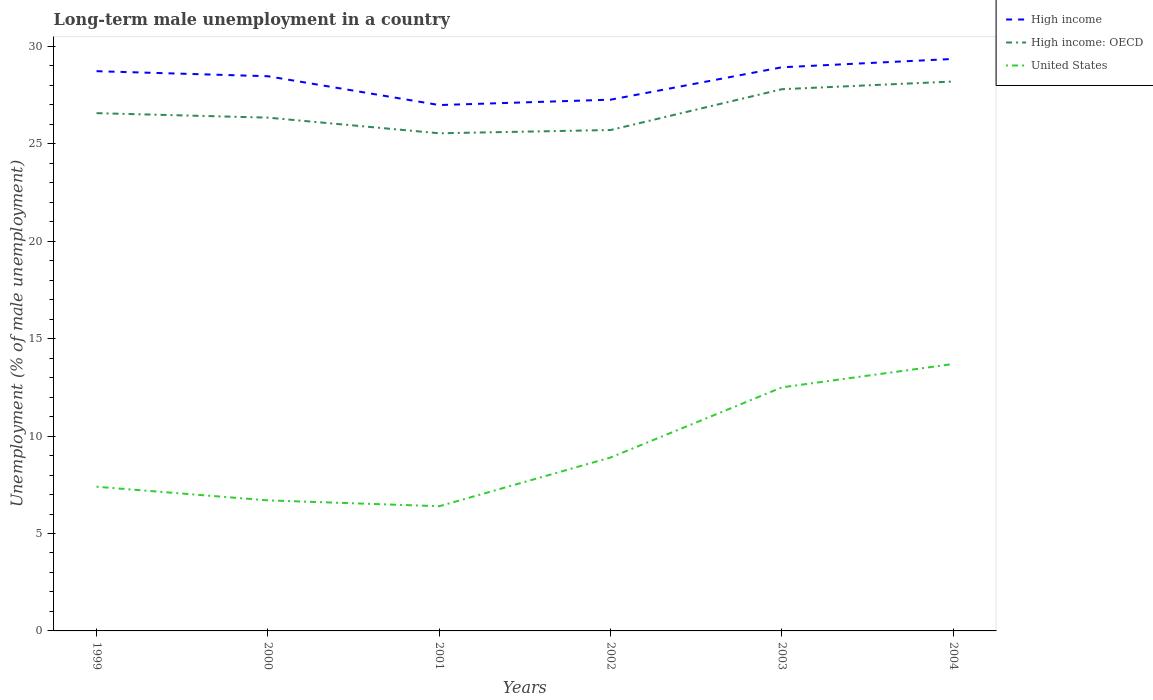Does the line corresponding to United States intersect with the line corresponding to High income?
Your response must be concise. No. Across all years, what is the maximum percentage of long-term unemployed male population in High income: OECD?
Provide a short and direct response. 25.54. What is the total percentage of long-term unemployed male population in High income in the graph?
Give a very brief answer. -2.37. What is the difference between the highest and the second highest percentage of long-term unemployed male population in High income?
Provide a succinct answer. 2.37. What is the difference between the highest and the lowest percentage of long-term unemployed male population in United States?
Offer a terse response. 2. Is the percentage of long-term unemployed male population in High income: OECD strictly greater than the percentage of long-term unemployed male population in High income over the years?
Your answer should be compact. Yes. Does the graph contain grids?
Provide a short and direct response. No. Where does the legend appear in the graph?
Give a very brief answer. Top right. How many legend labels are there?
Ensure brevity in your answer.  3. What is the title of the graph?
Your answer should be compact. Long-term male unemployment in a country. What is the label or title of the X-axis?
Offer a very short reply. Years. What is the label or title of the Y-axis?
Offer a very short reply. Unemployment (% of male unemployment). What is the Unemployment (% of male unemployment) in High income in 1999?
Make the answer very short. 28.73. What is the Unemployment (% of male unemployment) in High income: OECD in 1999?
Provide a short and direct response. 26.57. What is the Unemployment (% of male unemployment) of United States in 1999?
Your answer should be compact. 7.4. What is the Unemployment (% of male unemployment) in High income in 2000?
Provide a short and direct response. 28.47. What is the Unemployment (% of male unemployment) of High income: OECD in 2000?
Make the answer very short. 26.34. What is the Unemployment (% of male unemployment) in United States in 2000?
Give a very brief answer. 6.7. What is the Unemployment (% of male unemployment) of High income in 2001?
Ensure brevity in your answer.  26.99. What is the Unemployment (% of male unemployment) in High income: OECD in 2001?
Your answer should be very brief. 25.54. What is the Unemployment (% of male unemployment) in United States in 2001?
Your response must be concise. 6.4. What is the Unemployment (% of male unemployment) of High income in 2002?
Provide a succinct answer. 27.26. What is the Unemployment (% of male unemployment) in High income: OECD in 2002?
Make the answer very short. 25.71. What is the Unemployment (% of male unemployment) in United States in 2002?
Your answer should be compact. 8.9. What is the Unemployment (% of male unemployment) of High income in 2003?
Your answer should be very brief. 28.93. What is the Unemployment (% of male unemployment) in High income: OECD in 2003?
Your response must be concise. 27.8. What is the Unemployment (% of male unemployment) of High income in 2004?
Ensure brevity in your answer.  29.36. What is the Unemployment (% of male unemployment) in High income: OECD in 2004?
Offer a terse response. 28.2. What is the Unemployment (% of male unemployment) in United States in 2004?
Make the answer very short. 13.7. Across all years, what is the maximum Unemployment (% of male unemployment) of High income?
Ensure brevity in your answer.  29.36. Across all years, what is the maximum Unemployment (% of male unemployment) in High income: OECD?
Your response must be concise. 28.2. Across all years, what is the maximum Unemployment (% of male unemployment) of United States?
Offer a terse response. 13.7. Across all years, what is the minimum Unemployment (% of male unemployment) in High income?
Offer a terse response. 26.99. Across all years, what is the minimum Unemployment (% of male unemployment) of High income: OECD?
Give a very brief answer. 25.54. Across all years, what is the minimum Unemployment (% of male unemployment) of United States?
Keep it short and to the point. 6.4. What is the total Unemployment (% of male unemployment) in High income in the graph?
Make the answer very short. 169.73. What is the total Unemployment (% of male unemployment) of High income: OECD in the graph?
Offer a terse response. 160.16. What is the total Unemployment (% of male unemployment) of United States in the graph?
Make the answer very short. 55.6. What is the difference between the Unemployment (% of male unemployment) in High income in 1999 and that in 2000?
Ensure brevity in your answer.  0.26. What is the difference between the Unemployment (% of male unemployment) in High income: OECD in 1999 and that in 2000?
Your answer should be very brief. 0.23. What is the difference between the Unemployment (% of male unemployment) of High income in 1999 and that in 2001?
Your response must be concise. 1.74. What is the difference between the Unemployment (% of male unemployment) in High income: OECD in 1999 and that in 2001?
Your answer should be very brief. 1.03. What is the difference between the Unemployment (% of male unemployment) of United States in 1999 and that in 2001?
Provide a succinct answer. 1. What is the difference between the Unemployment (% of male unemployment) in High income in 1999 and that in 2002?
Ensure brevity in your answer.  1.46. What is the difference between the Unemployment (% of male unemployment) in High income: OECD in 1999 and that in 2002?
Provide a short and direct response. 0.87. What is the difference between the Unemployment (% of male unemployment) of United States in 1999 and that in 2002?
Offer a terse response. -1.5. What is the difference between the Unemployment (% of male unemployment) of High income in 1999 and that in 2003?
Offer a terse response. -0.2. What is the difference between the Unemployment (% of male unemployment) of High income: OECD in 1999 and that in 2003?
Give a very brief answer. -1.23. What is the difference between the Unemployment (% of male unemployment) of United States in 1999 and that in 2003?
Provide a succinct answer. -5.1. What is the difference between the Unemployment (% of male unemployment) in High income in 1999 and that in 2004?
Offer a very short reply. -0.63. What is the difference between the Unemployment (% of male unemployment) in High income: OECD in 1999 and that in 2004?
Ensure brevity in your answer.  -1.62. What is the difference between the Unemployment (% of male unemployment) of United States in 1999 and that in 2004?
Provide a short and direct response. -6.3. What is the difference between the Unemployment (% of male unemployment) in High income in 2000 and that in 2001?
Your answer should be compact. 1.48. What is the difference between the Unemployment (% of male unemployment) of High income: OECD in 2000 and that in 2001?
Your answer should be compact. 0.8. What is the difference between the Unemployment (% of male unemployment) in United States in 2000 and that in 2001?
Give a very brief answer. 0.3. What is the difference between the Unemployment (% of male unemployment) of High income in 2000 and that in 2002?
Your response must be concise. 1.2. What is the difference between the Unemployment (% of male unemployment) of High income: OECD in 2000 and that in 2002?
Your response must be concise. 0.64. What is the difference between the Unemployment (% of male unemployment) of High income in 2000 and that in 2003?
Your answer should be compact. -0.46. What is the difference between the Unemployment (% of male unemployment) in High income: OECD in 2000 and that in 2003?
Your answer should be very brief. -1.46. What is the difference between the Unemployment (% of male unemployment) of High income in 2000 and that in 2004?
Offer a terse response. -0.89. What is the difference between the Unemployment (% of male unemployment) in High income: OECD in 2000 and that in 2004?
Give a very brief answer. -1.85. What is the difference between the Unemployment (% of male unemployment) in High income in 2001 and that in 2002?
Your answer should be compact. -0.28. What is the difference between the Unemployment (% of male unemployment) in High income: OECD in 2001 and that in 2002?
Offer a terse response. -0.17. What is the difference between the Unemployment (% of male unemployment) in High income in 2001 and that in 2003?
Offer a terse response. -1.94. What is the difference between the Unemployment (% of male unemployment) of High income: OECD in 2001 and that in 2003?
Provide a short and direct response. -2.26. What is the difference between the Unemployment (% of male unemployment) in High income in 2001 and that in 2004?
Provide a succinct answer. -2.37. What is the difference between the Unemployment (% of male unemployment) of High income: OECD in 2001 and that in 2004?
Your answer should be very brief. -2.66. What is the difference between the Unemployment (% of male unemployment) of High income in 2002 and that in 2003?
Provide a succinct answer. -1.66. What is the difference between the Unemployment (% of male unemployment) of High income: OECD in 2002 and that in 2003?
Provide a short and direct response. -2.1. What is the difference between the Unemployment (% of male unemployment) of High income in 2002 and that in 2004?
Ensure brevity in your answer.  -2.09. What is the difference between the Unemployment (% of male unemployment) of High income: OECD in 2002 and that in 2004?
Ensure brevity in your answer.  -2.49. What is the difference between the Unemployment (% of male unemployment) in High income in 2003 and that in 2004?
Keep it short and to the point. -0.43. What is the difference between the Unemployment (% of male unemployment) in High income: OECD in 2003 and that in 2004?
Make the answer very short. -0.39. What is the difference between the Unemployment (% of male unemployment) of High income in 1999 and the Unemployment (% of male unemployment) of High income: OECD in 2000?
Make the answer very short. 2.38. What is the difference between the Unemployment (% of male unemployment) of High income in 1999 and the Unemployment (% of male unemployment) of United States in 2000?
Make the answer very short. 22.03. What is the difference between the Unemployment (% of male unemployment) in High income: OECD in 1999 and the Unemployment (% of male unemployment) in United States in 2000?
Keep it short and to the point. 19.87. What is the difference between the Unemployment (% of male unemployment) in High income in 1999 and the Unemployment (% of male unemployment) in High income: OECD in 2001?
Provide a succinct answer. 3.19. What is the difference between the Unemployment (% of male unemployment) of High income in 1999 and the Unemployment (% of male unemployment) of United States in 2001?
Offer a terse response. 22.33. What is the difference between the Unemployment (% of male unemployment) of High income: OECD in 1999 and the Unemployment (% of male unemployment) of United States in 2001?
Your answer should be compact. 20.17. What is the difference between the Unemployment (% of male unemployment) of High income in 1999 and the Unemployment (% of male unemployment) of High income: OECD in 2002?
Your answer should be very brief. 3.02. What is the difference between the Unemployment (% of male unemployment) of High income in 1999 and the Unemployment (% of male unemployment) of United States in 2002?
Give a very brief answer. 19.83. What is the difference between the Unemployment (% of male unemployment) of High income: OECD in 1999 and the Unemployment (% of male unemployment) of United States in 2002?
Your answer should be compact. 17.67. What is the difference between the Unemployment (% of male unemployment) of High income in 1999 and the Unemployment (% of male unemployment) of High income: OECD in 2003?
Your answer should be very brief. 0.92. What is the difference between the Unemployment (% of male unemployment) of High income in 1999 and the Unemployment (% of male unemployment) of United States in 2003?
Offer a very short reply. 16.23. What is the difference between the Unemployment (% of male unemployment) in High income: OECD in 1999 and the Unemployment (% of male unemployment) in United States in 2003?
Your answer should be compact. 14.07. What is the difference between the Unemployment (% of male unemployment) in High income in 1999 and the Unemployment (% of male unemployment) in High income: OECD in 2004?
Provide a succinct answer. 0.53. What is the difference between the Unemployment (% of male unemployment) of High income in 1999 and the Unemployment (% of male unemployment) of United States in 2004?
Ensure brevity in your answer.  15.03. What is the difference between the Unemployment (% of male unemployment) in High income: OECD in 1999 and the Unemployment (% of male unemployment) in United States in 2004?
Keep it short and to the point. 12.87. What is the difference between the Unemployment (% of male unemployment) in High income in 2000 and the Unemployment (% of male unemployment) in High income: OECD in 2001?
Provide a short and direct response. 2.93. What is the difference between the Unemployment (% of male unemployment) in High income in 2000 and the Unemployment (% of male unemployment) in United States in 2001?
Provide a succinct answer. 22.07. What is the difference between the Unemployment (% of male unemployment) in High income: OECD in 2000 and the Unemployment (% of male unemployment) in United States in 2001?
Ensure brevity in your answer.  19.94. What is the difference between the Unemployment (% of male unemployment) in High income in 2000 and the Unemployment (% of male unemployment) in High income: OECD in 2002?
Offer a very short reply. 2.76. What is the difference between the Unemployment (% of male unemployment) in High income in 2000 and the Unemployment (% of male unemployment) in United States in 2002?
Provide a short and direct response. 19.57. What is the difference between the Unemployment (% of male unemployment) in High income: OECD in 2000 and the Unemployment (% of male unemployment) in United States in 2002?
Your answer should be very brief. 17.44. What is the difference between the Unemployment (% of male unemployment) of High income in 2000 and the Unemployment (% of male unemployment) of High income: OECD in 2003?
Offer a terse response. 0.67. What is the difference between the Unemployment (% of male unemployment) of High income in 2000 and the Unemployment (% of male unemployment) of United States in 2003?
Offer a terse response. 15.97. What is the difference between the Unemployment (% of male unemployment) in High income: OECD in 2000 and the Unemployment (% of male unemployment) in United States in 2003?
Your answer should be compact. 13.84. What is the difference between the Unemployment (% of male unemployment) of High income in 2000 and the Unemployment (% of male unemployment) of High income: OECD in 2004?
Make the answer very short. 0.27. What is the difference between the Unemployment (% of male unemployment) in High income in 2000 and the Unemployment (% of male unemployment) in United States in 2004?
Offer a very short reply. 14.77. What is the difference between the Unemployment (% of male unemployment) of High income: OECD in 2000 and the Unemployment (% of male unemployment) of United States in 2004?
Keep it short and to the point. 12.64. What is the difference between the Unemployment (% of male unemployment) of High income in 2001 and the Unemployment (% of male unemployment) of High income: OECD in 2002?
Keep it short and to the point. 1.28. What is the difference between the Unemployment (% of male unemployment) in High income in 2001 and the Unemployment (% of male unemployment) in United States in 2002?
Keep it short and to the point. 18.09. What is the difference between the Unemployment (% of male unemployment) of High income: OECD in 2001 and the Unemployment (% of male unemployment) of United States in 2002?
Offer a very short reply. 16.64. What is the difference between the Unemployment (% of male unemployment) in High income in 2001 and the Unemployment (% of male unemployment) in High income: OECD in 2003?
Provide a succinct answer. -0.81. What is the difference between the Unemployment (% of male unemployment) in High income in 2001 and the Unemployment (% of male unemployment) in United States in 2003?
Your answer should be very brief. 14.49. What is the difference between the Unemployment (% of male unemployment) of High income: OECD in 2001 and the Unemployment (% of male unemployment) of United States in 2003?
Your answer should be compact. 13.04. What is the difference between the Unemployment (% of male unemployment) in High income in 2001 and the Unemployment (% of male unemployment) in High income: OECD in 2004?
Offer a terse response. -1.21. What is the difference between the Unemployment (% of male unemployment) in High income in 2001 and the Unemployment (% of male unemployment) in United States in 2004?
Offer a terse response. 13.29. What is the difference between the Unemployment (% of male unemployment) in High income: OECD in 2001 and the Unemployment (% of male unemployment) in United States in 2004?
Your response must be concise. 11.84. What is the difference between the Unemployment (% of male unemployment) of High income in 2002 and the Unemployment (% of male unemployment) of High income: OECD in 2003?
Your response must be concise. -0.54. What is the difference between the Unemployment (% of male unemployment) of High income in 2002 and the Unemployment (% of male unemployment) of United States in 2003?
Your response must be concise. 14.76. What is the difference between the Unemployment (% of male unemployment) in High income: OECD in 2002 and the Unemployment (% of male unemployment) in United States in 2003?
Provide a succinct answer. 13.21. What is the difference between the Unemployment (% of male unemployment) of High income in 2002 and the Unemployment (% of male unemployment) of High income: OECD in 2004?
Make the answer very short. -0.93. What is the difference between the Unemployment (% of male unemployment) in High income in 2002 and the Unemployment (% of male unemployment) in United States in 2004?
Ensure brevity in your answer.  13.56. What is the difference between the Unemployment (% of male unemployment) of High income: OECD in 2002 and the Unemployment (% of male unemployment) of United States in 2004?
Offer a terse response. 12.01. What is the difference between the Unemployment (% of male unemployment) in High income in 2003 and the Unemployment (% of male unemployment) in High income: OECD in 2004?
Make the answer very short. 0.73. What is the difference between the Unemployment (% of male unemployment) in High income in 2003 and the Unemployment (% of male unemployment) in United States in 2004?
Your answer should be very brief. 15.23. What is the difference between the Unemployment (% of male unemployment) in High income: OECD in 2003 and the Unemployment (% of male unemployment) in United States in 2004?
Your answer should be compact. 14.1. What is the average Unemployment (% of male unemployment) in High income per year?
Give a very brief answer. 28.29. What is the average Unemployment (% of male unemployment) in High income: OECD per year?
Offer a very short reply. 26.69. What is the average Unemployment (% of male unemployment) of United States per year?
Keep it short and to the point. 9.27. In the year 1999, what is the difference between the Unemployment (% of male unemployment) in High income and Unemployment (% of male unemployment) in High income: OECD?
Make the answer very short. 2.15. In the year 1999, what is the difference between the Unemployment (% of male unemployment) in High income and Unemployment (% of male unemployment) in United States?
Give a very brief answer. 21.33. In the year 1999, what is the difference between the Unemployment (% of male unemployment) of High income: OECD and Unemployment (% of male unemployment) of United States?
Give a very brief answer. 19.17. In the year 2000, what is the difference between the Unemployment (% of male unemployment) of High income and Unemployment (% of male unemployment) of High income: OECD?
Offer a very short reply. 2.12. In the year 2000, what is the difference between the Unemployment (% of male unemployment) in High income and Unemployment (% of male unemployment) in United States?
Offer a terse response. 21.77. In the year 2000, what is the difference between the Unemployment (% of male unemployment) of High income: OECD and Unemployment (% of male unemployment) of United States?
Offer a terse response. 19.64. In the year 2001, what is the difference between the Unemployment (% of male unemployment) in High income and Unemployment (% of male unemployment) in High income: OECD?
Offer a very short reply. 1.45. In the year 2001, what is the difference between the Unemployment (% of male unemployment) in High income and Unemployment (% of male unemployment) in United States?
Your answer should be compact. 20.59. In the year 2001, what is the difference between the Unemployment (% of male unemployment) in High income: OECD and Unemployment (% of male unemployment) in United States?
Your answer should be compact. 19.14. In the year 2002, what is the difference between the Unemployment (% of male unemployment) of High income and Unemployment (% of male unemployment) of High income: OECD?
Keep it short and to the point. 1.56. In the year 2002, what is the difference between the Unemployment (% of male unemployment) of High income and Unemployment (% of male unemployment) of United States?
Ensure brevity in your answer.  18.36. In the year 2002, what is the difference between the Unemployment (% of male unemployment) of High income: OECD and Unemployment (% of male unemployment) of United States?
Ensure brevity in your answer.  16.81. In the year 2003, what is the difference between the Unemployment (% of male unemployment) of High income and Unemployment (% of male unemployment) of High income: OECD?
Your answer should be very brief. 1.13. In the year 2003, what is the difference between the Unemployment (% of male unemployment) in High income and Unemployment (% of male unemployment) in United States?
Provide a succinct answer. 16.43. In the year 2003, what is the difference between the Unemployment (% of male unemployment) of High income: OECD and Unemployment (% of male unemployment) of United States?
Your answer should be very brief. 15.3. In the year 2004, what is the difference between the Unemployment (% of male unemployment) of High income and Unemployment (% of male unemployment) of High income: OECD?
Your answer should be very brief. 1.16. In the year 2004, what is the difference between the Unemployment (% of male unemployment) of High income and Unemployment (% of male unemployment) of United States?
Provide a succinct answer. 15.66. In the year 2004, what is the difference between the Unemployment (% of male unemployment) of High income: OECD and Unemployment (% of male unemployment) of United States?
Make the answer very short. 14.5. What is the ratio of the Unemployment (% of male unemployment) in High income in 1999 to that in 2000?
Your answer should be very brief. 1.01. What is the ratio of the Unemployment (% of male unemployment) in High income: OECD in 1999 to that in 2000?
Your answer should be very brief. 1.01. What is the ratio of the Unemployment (% of male unemployment) of United States in 1999 to that in 2000?
Your response must be concise. 1.1. What is the ratio of the Unemployment (% of male unemployment) of High income in 1999 to that in 2001?
Your response must be concise. 1.06. What is the ratio of the Unemployment (% of male unemployment) of High income: OECD in 1999 to that in 2001?
Offer a terse response. 1.04. What is the ratio of the Unemployment (% of male unemployment) in United States in 1999 to that in 2001?
Offer a terse response. 1.16. What is the ratio of the Unemployment (% of male unemployment) in High income in 1999 to that in 2002?
Ensure brevity in your answer.  1.05. What is the ratio of the Unemployment (% of male unemployment) in High income: OECD in 1999 to that in 2002?
Your answer should be compact. 1.03. What is the ratio of the Unemployment (% of male unemployment) of United States in 1999 to that in 2002?
Ensure brevity in your answer.  0.83. What is the ratio of the Unemployment (% of male unemployment) of High income: OECD in 1999 to that in 2003?
Your answer should be compact. 0.96. What is the ratio of the Unemployment (% of male unemployment) in United States in 1999 to that in 2003?
Your response must be concise. 0.59. What is the ratio of the Unemployment (% of male unemployment) of High income in 1999 to that in 2004?
Your answer should be compact. 0.98. What is the ratio of the Unemployment (% of male unemployment) of High income: OECD in 1999 to that in 2004?
Your answer should be very brief. 0.94. What is the ratio of the Unemployment (% of male unemployment) of United States in 1999 to that in 2004?
Keep it short and to the point. 0.54. What is the ratio of the Unemployment (% of male unemployment) in High income in 2000 to that in 2001?
Provide a succinct answer. 1.05. What is the ratio of the Unemployment (% of male unemployment) in High income: OECD in 2000 to that in 2001?
Offer a terse response. 1.03. What is the ratio of the Unemployment (% of male unemployment) in United States in 2000 to that in 2001?
Your response must be concise. 1.05. What is the ratio of the Unemployment (% of male unemployment) in High income in 2000 to that in 2002?
Your answer should be very brief. 1.04. What is the ratio of the Unemployment (% of male unemployment) in High income: OECD in 2000 to that in 2002?
Your answer should be compact. 1.02. What is the ratio of the Unemployment (% of male unemployment) in United States in 2000 to that in 2002?
Make the answer very short. 0.75. What is the ratio of the Unemployment (% of male unemployment) of High income in 2000 to that in 2003?
Offer a terse response. 0.98. What is the ratio of the Unemployment (% of male unemployment) of High income: OECD in 2000 to that in 2003?
Provide a short and direct response. 0.95. What is the ratio of the Unemployment (% of male unemployment) of United States in 2000 to that in 2003?
Give a very brief answer. 0.54. What is the ratio of the Unemployment (% of male unemployment) of High income in 2000 to that in 2004?
Keep it short and to the point. 0.97. What is the ratio of the Unemployment (% of male unemployment) in High income: OECD in 2000 to that in 2004?
Give a very brief answer. 0.93. What is the ratio of the Unemployment (% of male unemployment) in United States in 2000 to that in 2004?
Offer a terse response. 0.49. What is the ratio of the Unemployment (% of male unemployment) in High income: OECD in 2001 to that in 2002?
Offer a terse response. 0.99. What is the ratio of the Unemployment (% of male unemployment) of United States in 2001 to that in 2002?
Give a very brief answer. 0.72. What is the ratio of the Unemployment (% of male unemployment) of High income in 2001 to that in 2003?
Ensure brevity in your answer.  0.93. What is the ratio of the Unemployment (% of male unemployment) in High income: OECD in 2001 to that in 2003?
Keep it short and to the point. 0.92. What is the ratio of the Unemployment (% of male unemployment) in United States in 2001 to that in 2003?
Ensure brevity in your answer.  0.51. What is the ratio of the Unemployment (% of male unemployment) of High income in 2001 to that in 2004?
Give a very brief answer. 0.92. What is the ratio of the Unemployment (% of male unemployment) in High income: OECD in 2001 to that in 2004?
Your response must be concise. 0.91. What is the ratio of the Unemployment (% of male unemployment) in United States in 2001 to that in 2004?
Offer a terse response. 0.47. What is the ratio of the Unemployment (% of male unemployment) of High income in 2002 to that in 2003?
Your answer should be very brief. 0.94. What is the ratio of the Unemployment (% of male unemployment) of High income: OECD in 2002 to that in 2003?
Make the answer very short. 0.92. What is the ratio of the Unemployment (% of male unemployment) in United States in 2002 to that in 2003?
Give a very brief answer. 0.71. What is the ratio of the Unemployment (% of male unemployment) of High income in 2002 to that in 2004?
Offer a very short reply. 0.93. What is the ratio of the Unemployment (% of male unemployment) of High income: OECD in 2002 to that in 2004?
Offer a very short reply. 0.91. What is the ratio of the Unemployment (% of male unemployment) of United States in 2002 to that in 2004?
Your response must be concise. 0.65. What is the ratio of the Unemployment (% of male unemployment) in High income in 2003 to that in 2004?
Make the answer very short. 0.99. What is the ratio of the Unemployment (% of male unemployment) in United States in 2003 to that in 2004?
Your answer should be very brief. 0.91. What is the difference between the highest and the second highest Unemployment (% of male unemployment) of High income?
Make the answer very short. 0.43. What is the difference between the highest and the second highest Unemployment (% of male unemployment) in High income: OECD?
Your answer should be very brief. 0.39. What is the difference between the highest and the second highest Unemployment (% of male unemployment) in United States?
Make the answer very short. 1.2. What is the difference between the highest and the lowest Unemployment (% of male unemployment) in High income?
Your answer should be compact. 2.37. What is the difference between the highest and the lowest Unemployment (% of male unemployment) of High income: OECD?
Ensure brevity in your answer.  2.66. What is the difference between the highest and the lowest Unemployment (% of male unemployment) of United States?
Offer a terse response. 7.3. 